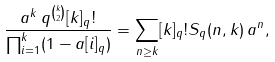Convert formula to latex. <formula><loc_0><loc_0><loc_500><loc_500>\frac { a ^ { k } \, q ^ { k \choose 2 } [ k ] _ { q } ! } { \prod _ { i = 1 } ^ { k } ( 1 - a [ i ] _ { q } ) } = \sum _ { n \geq k } [ k ] _ { q } ! S _ { q } ( n , k ) \, a ^ { n } ,</formula> 